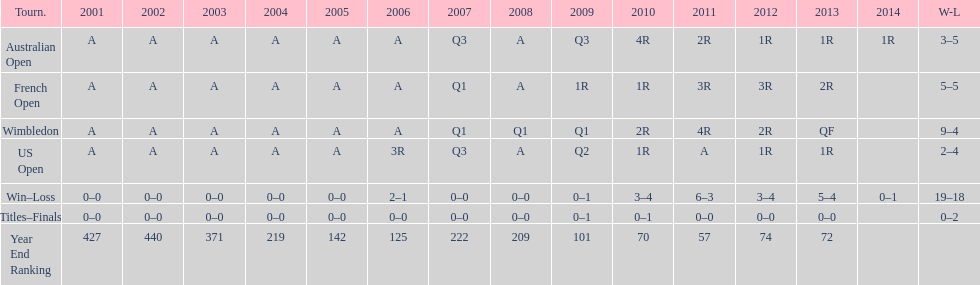Which tournament has the largest total win record? Wimbledon. 